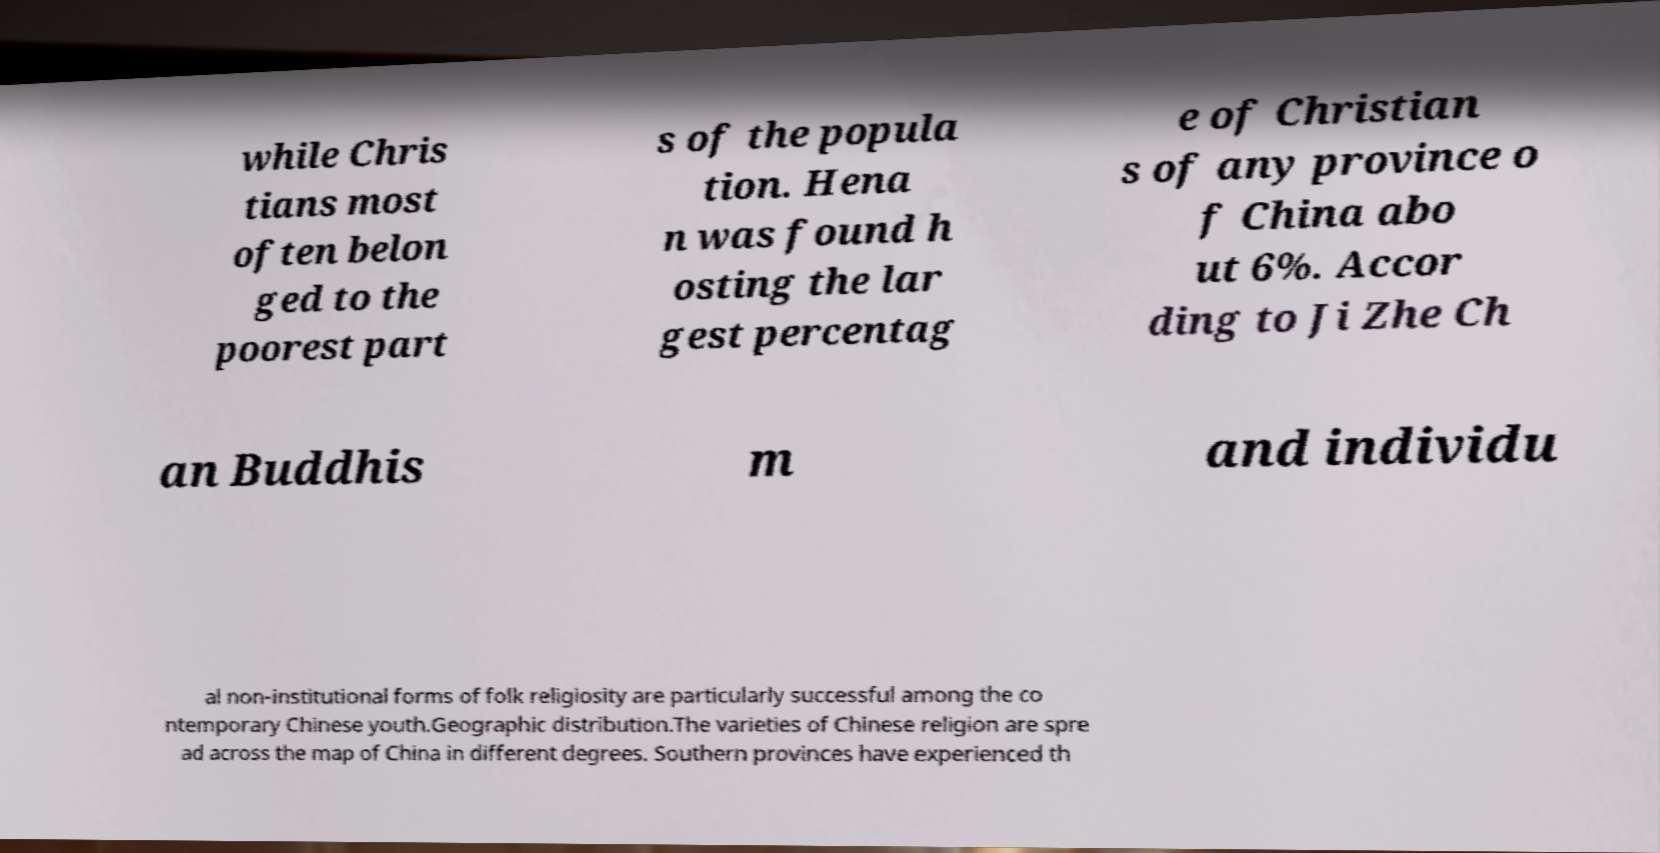Could you assist in decoding the text presented in this image and type it out clearly? while Chris tians most often belon ged to the poorest part s of the popula tion. Hena n was found h osting the lar gest percentag e of Christian s of any province o f China abo ut 6%. Accor ding to Ji Zhe Ch an Buddhis m and individu al non-institutional forms of folk religiosity are particularly successful among the co ntemporary Chinese youth.Geographic distribution.The varieties of Chinese religion are spre ad across the map of China in different degrees. Southern provinces have experienced th 